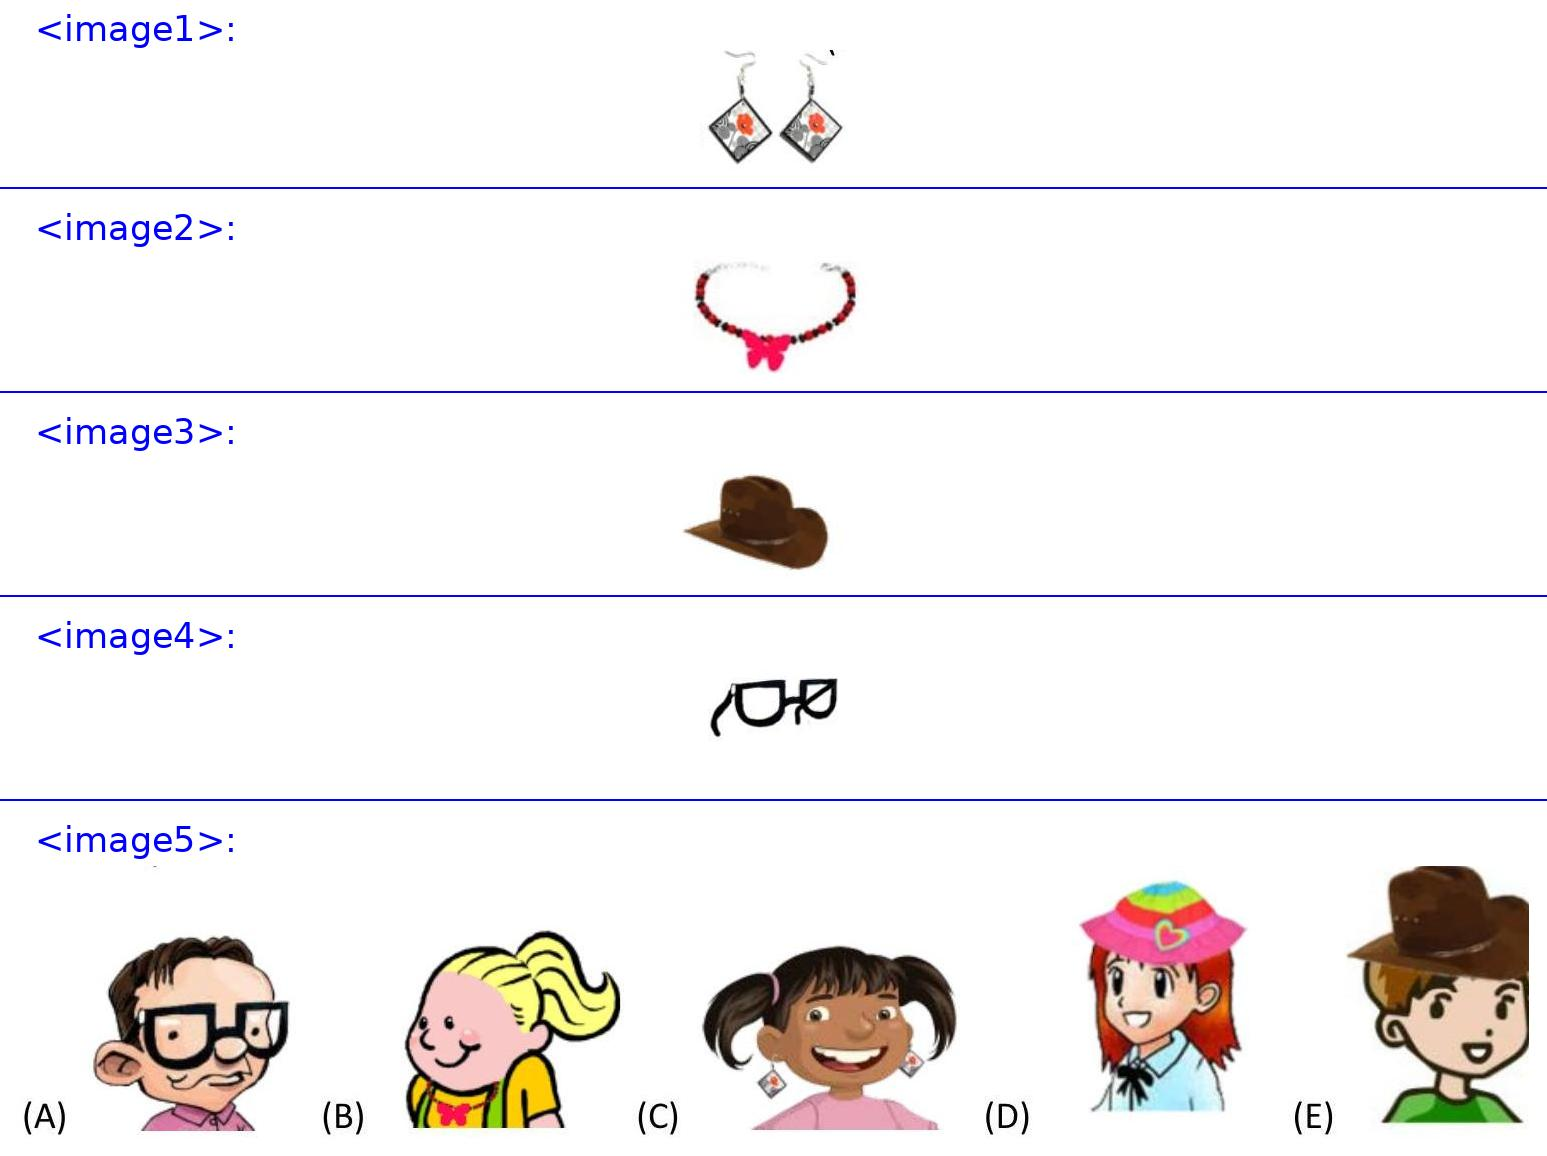<image4> How do these glasses reflect the personality of its wearer? The glasses shown have a classic, sophisticated design with a rectangular frame, indicating that the wearer might prefer simplicity in style but also values professionalism and a serious demeanor. They are typically chosen by individuals who engage in intellectual activities. 